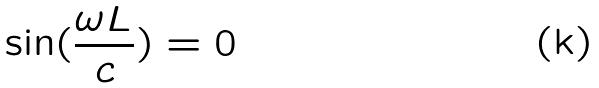Convert formula to latex. <formula><loc_0><loc_0><loc_500><loc_500>\sin ( \frac { \omega L } { c } ) = 0</formula> 